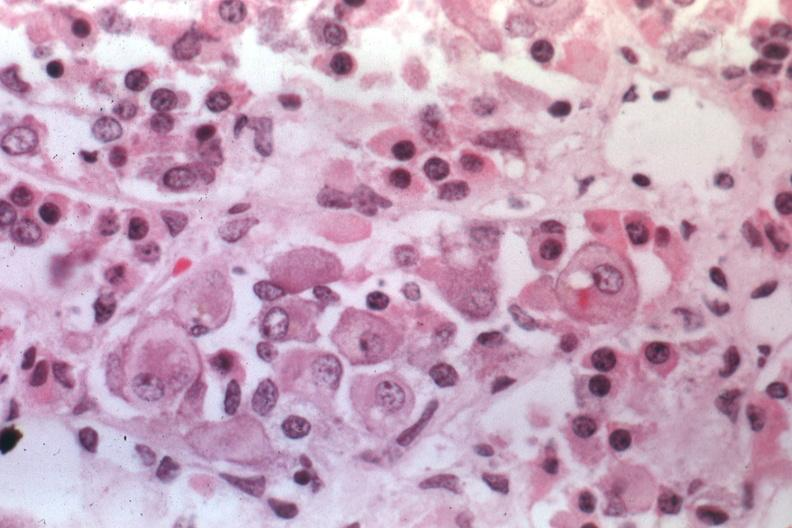s endocrine present?
Answer the question using a single word or phrase. Yes 